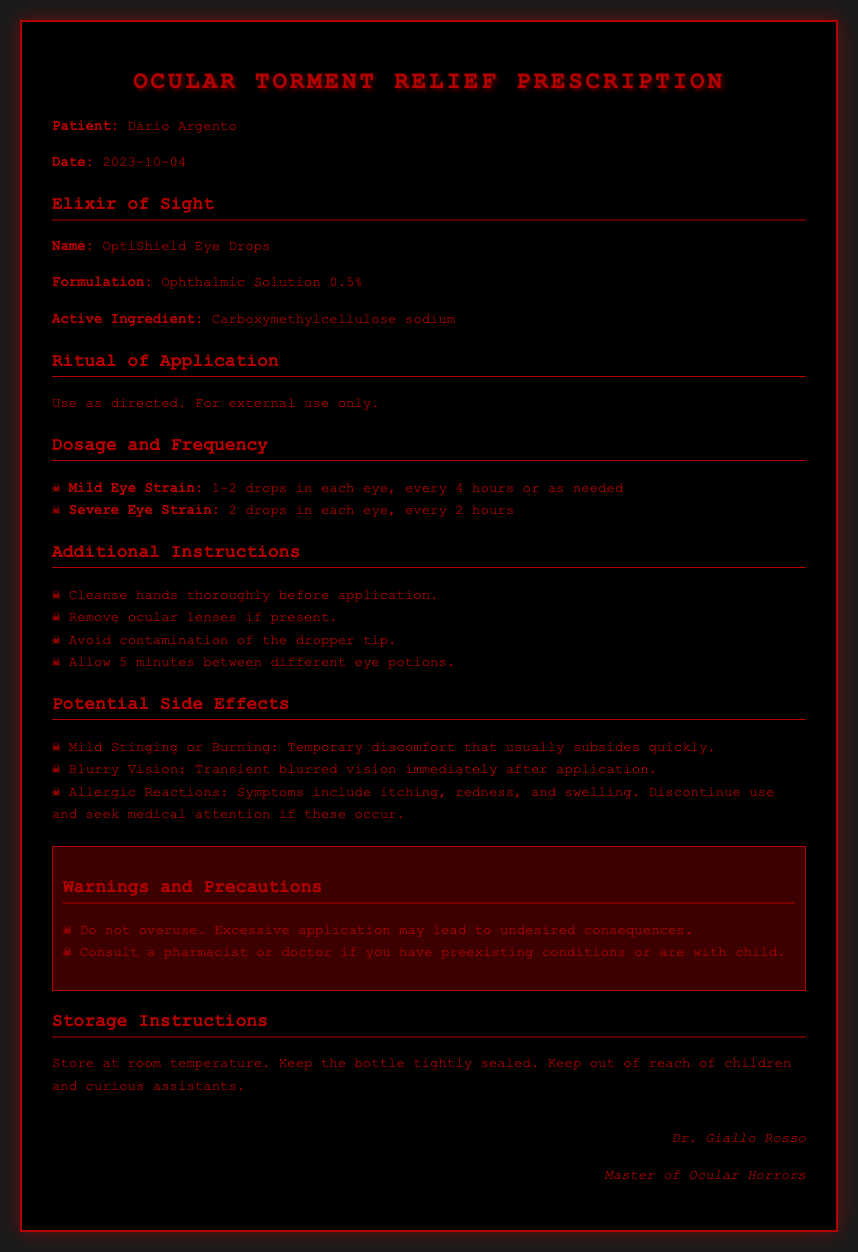What is the patient's name? The patient's name is mentioned at the beginning of the prescription document as "Dario Argento."
Answer: Dario Argento What is the date of the prescription? The date of the prescription is specified under the patient's name.
Answer: 2023-10-04 What is the active ingredient in the eye drops? The active ingredient is listed in the formulation section of the document.
Answer: Carboxymethylcellulose sodium How often should one apply eye drops for severe eye strain? The dosage frequency for severe eye strain is detailed in the dosage section.
Answer: Every 2 hours What should you do if allergic reactions occur? The document outlines actions to take in case of allergic reactions.
Answer: Discontinue use and seek medical attention What is the storage instruction for the eye drops? The storage instruction is provided at the end of the prescription.
Answer: Store at room temperature What symptom might cause temporary discomfort after application? Some side effects listed include mild stinging or burning, indicating temporary discomfort.
Answer: Mild Stinging or Burning How many drops should be applied for mild eye strain? The required number of drops for mild eye strain is specified in the dosage section.
Answer: 1-2 drops What is advised before applying the eye drops? Additional instructions include cleansing hands thoroughly before application.
Answer: Cleanse hands thoroughly 